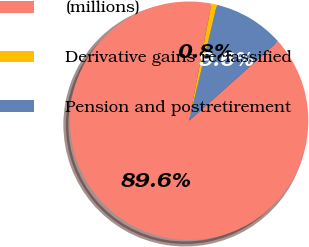Convert chart. <chart><loc_0><loc_0><loc_500><loc_500><pie_chart><fcel>(millions)<fcel>Derivative gains reclassified<fcel>Pension and postretirement<nl><fcel>89.61%<fcel>0.75%<fcel>9.64%<nl></chart> 